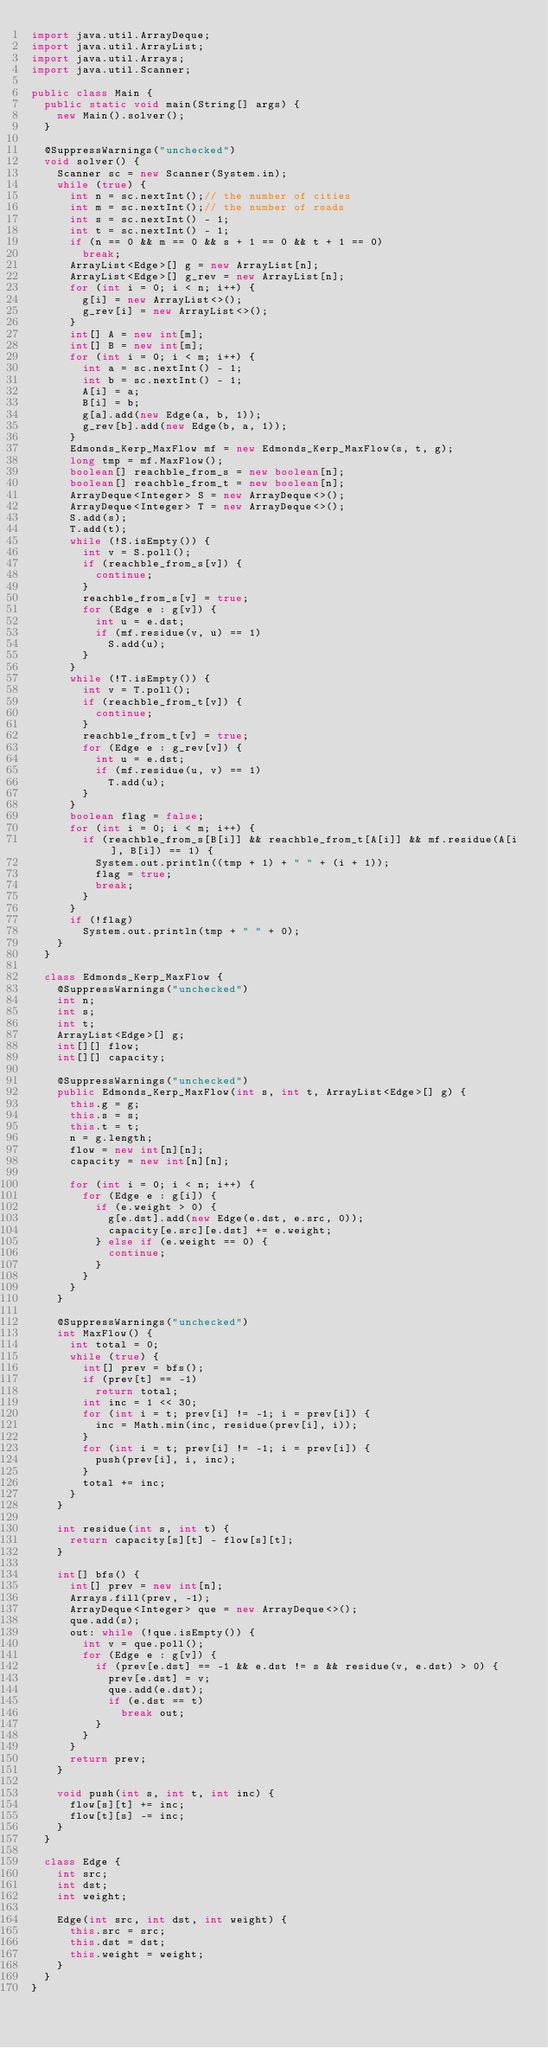<code> <loc_0><loc_0><loc_500><loc_500><_Java_>import java.util.ArrayDeque;
import java.util.ArrayList;
import java.util.Arrays;
import java.util.Scanner;

public class Main {
	public static void main(String[] args) {
		new Main().solver();
	}

	@SuppressWarnings("unchecked")
	void solver() {
		Scanner sc = new Scanner(System.in);
		while (true) {
			int n = sc.nextInt();// the number of cities
			int m = sc.nextInt();// the number of roads
			int s = sc.nextInt() - 1;
			int t = sc.nextInt() - 1;
			if (n == 0 && m == 0 && s + 1 == 0 && t + 1 == 0)
				break;
			ArrayList<Edge>[] g = new ArrayList[n];
			ArrayList<Edge>[] g_rev = new ArrayList[n];
			for (int i = 0; i < n; i++) {
				g[i] = new ArrayList<>();
				g_rev[i] = new ArrayList<>();
			}
			int[] A = new int[m];
			int[] B = new int[m];
			for (int i = 0; i < m; i++) {
				int a = sc.nextInt() - 1;
				int b = sc.nextInt() - 1;
				A[i] = a;
				B[i] = b;
				g[a].add(new Edge(a, b, 1));
				g_rev[b].add(new Edge(b, a, 1));
			}
			Edmonds_Kerp_MaxFlow mf = new Edmonds_Kerp_MaxFlow(s, t, g);
			long tmp = mf.MaxFlow();
			boolean[] reachble_from_s = new boolean[n];
			boolean[] reachble_from_t = new boolean[n];
			ArrayDeque<Integer> S = new ArrayDeque<>();
			ArrayDeque<Integer> T = new ArrayDeque<>();
			S.add(s);
			T.add(t);
			while (!S.isEmpty()) {
				int v = S.poll();
				if (reachble_from_s[v]) {
					continue;
				}
				reachble_from_s[v] = true;
				for (Edge e : g[v]) {
					int u = e.dst;
					if (mf.residue(v, u) == 1)
						S.add(u);
				}
			}
			while (!T.isEmpty()) {
				int v = T.poll();
				if (reachble_from_t[v]) {
					continue;
				}
				reachble_from_t[v] = true;
				for (Edge e : g_rev[v]) {
					int u = e.dst;
					if (mf.residue(u, v) == 1)
						T.add(u);
				}
			}
			boolean flag = false;
			for (int i = 0; i < m; i++) {
				if (reachble_from_s[B[i]] && reachble_from_t[A[i]] && mf.residue(A[i], B[i]) == 1) {
					System.out.println((tmp + 1) + " " + (i + 1));
					flag = true;
					break;
				}
			}
			if (!flag)
				System.out.println(tmp + " " + 0);
		}
	}

	class Edmonds_Kerp_MaxFlow {
		@SuppressWarnings("unchecked")
		int n;
		int s;
		int t;
		ArrayList<Edge>[] g;
		int[][] flow;
		int[][] capacity;

		@SuppressWarnings("unchecked")
		public Edmonds_Kerp_MaxFlow(int s, int t, ArrayList<Edge>[] g) {
			this.g = g;
			this.s = s;
			this.t = t;
			n = g.length;
			flow = new int[n][n];
			capacity = new int[n][n];

			for (int i = 0; i < n; i++) {
				for (Edge e : g[i]) {
					if (e.weight > 0) {
						g[e.dst].add(new Edge(e.dst, e.src, 0));
						capacity[e.src][e.dst] += e.weight;
					} else if (e.weight == 0) {
						continue;
					}
				}
			}
		}

		@SuppressWarnings("unchecked")
		int MaxFlow() {
			int total = 0;
			while (true) {
				int[] prev = bfs();
				if (prev[t] == -1)
					return total;
				int inc = 1 << 30;
				for (int i = t; prev[i] != -1; i = prev[i]) {
					inc = Math.min(inc, residue(prev[i], i));
				}
				for (int i = t; prev[i] != -1; i = prev[i]) {
					push(prev[i], i, inc);
				}
				total += inc;
			}
		}

		int residue(int s, int t) {
			return capacity[s][t] - flow[s][t];
		}

		int[] bfs() {
			int[] prev = new int[n];
			Arrays.fill(prev, -1);
			ArrayDeque<Integer> que = new ArrayDeque<>();
			que.add(s);
			out: while (!que.isEmpty()) {
				int v = que.poll();
				for (Edge e : g[v]) {
					if (prev[e.dst] == -1 && e.dst != s && residue(v, e.dst) > 0) {
						prev[e.dst] = v;
						que.add(e.dst);
						if (e.dst == t)
							break out;
					}
				}
			}
			return prev;
		}

		void push(int s, int t, int inc) {
			flow[s][t] += inc;
			flow[t][s] -= inc;
		}
	}

	class Edge {
		int src;
		int dst;
		int weight;

		Edge(int src, int dst, int weight) {
			this.src = src;
			this.dst = dst;
			this.weight = weight;
		}
	}
}</code> 